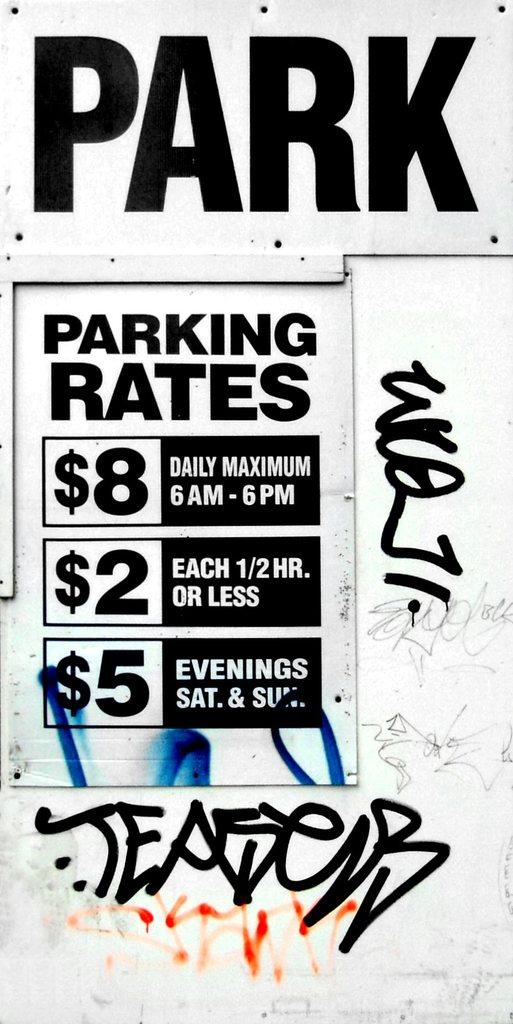How many dollars is the daily maximum?
Make the answer very short. 8. What are the rates for?
Offer a very short reply. Parking. 